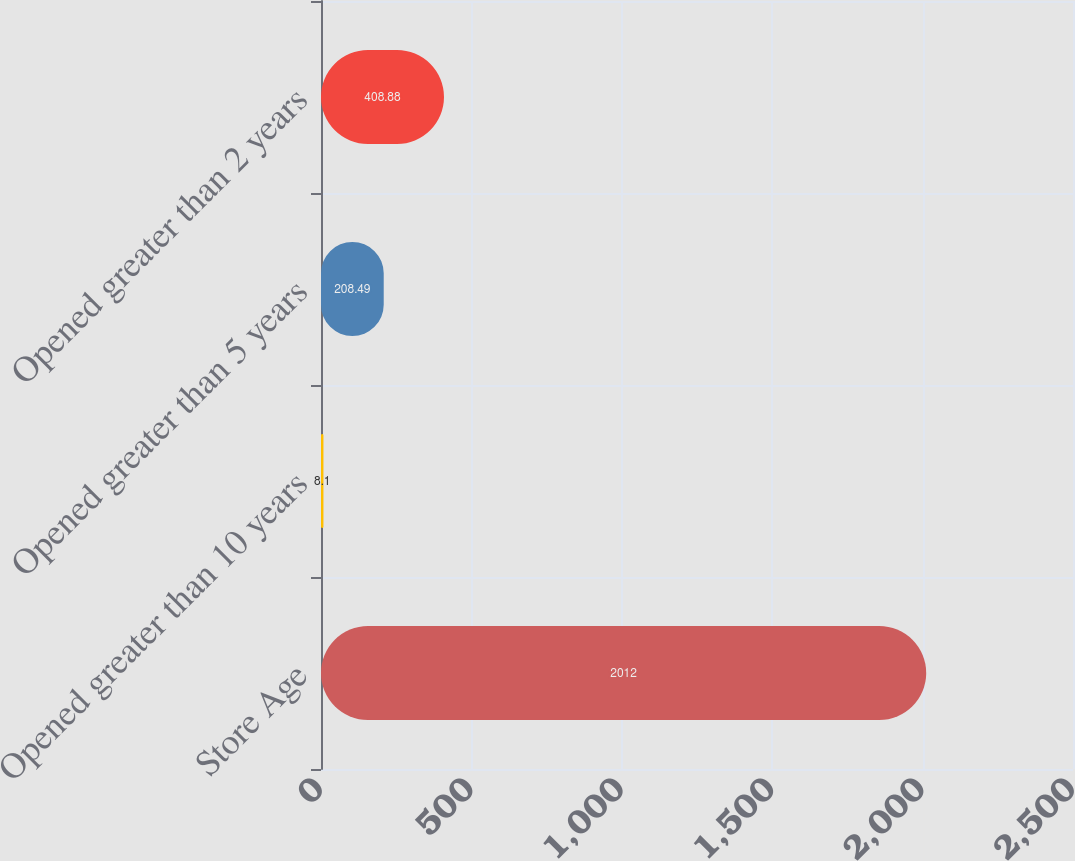Convert chart to OTSL. <chart><loc_0><loc_0><loc_500><loc_500><bar_chart><fcel>Store Age<fcel>Opened greater than 10 years<fcel>Opened greater than 5 years<fcel>Opened greater than 2 years<nl><fcel>2012<fcel>8.1<fcel>208.49<fcel>408.88<nl></chart> 